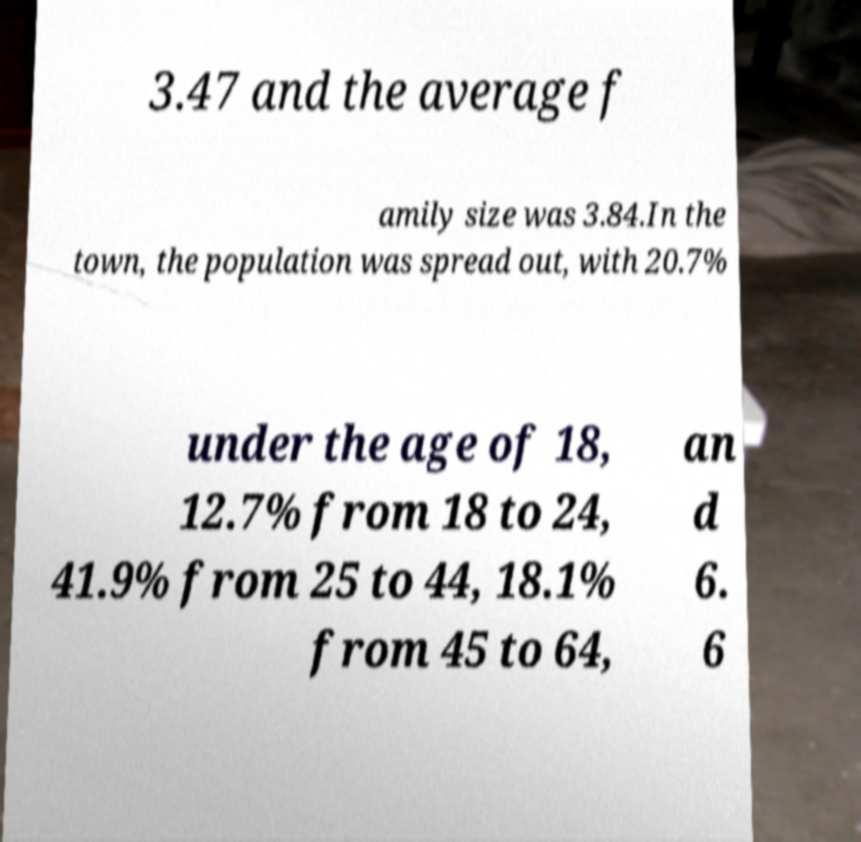Can you read and provide the text displayed in the image?This photo seems to have some interesting text. Can you extract and type it out for me? 3.47 and the average f amily size was 3.84.In the town, the population was spread out, with 20.7% under the age of 18, 12.7% from 18 to 24, 41.9% from 25 to 44, 18.1% from 45 to 64, an d 6. 6 